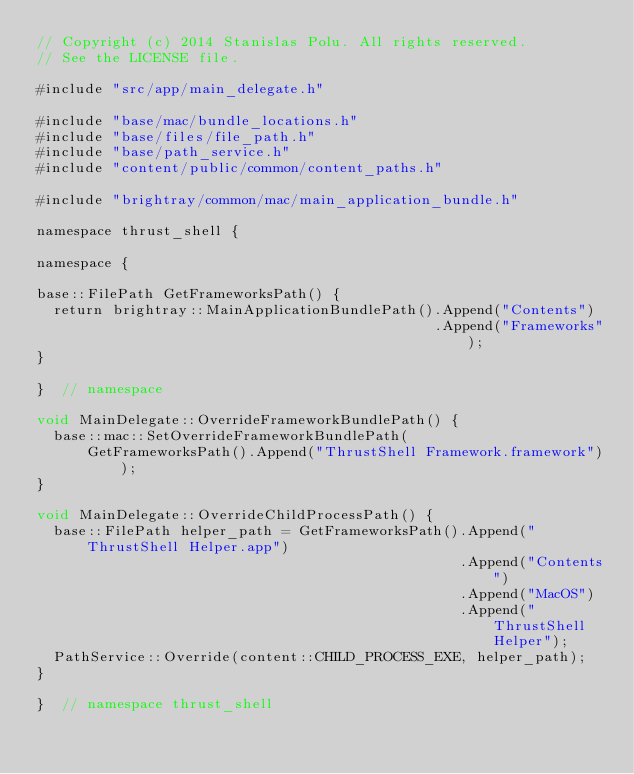Convert code to text. <code><loc_0><loc_0><loc_500><loc_500><_ObjectiveC_>// Copyright (c) 2014 Stanislas Polu. All rights reserved.
// See the LICENSE file.

#include "src/app/main_delegate.h"

#include "base/mac/bundle_locations.h"
#include "base/files/file_path.h"
#include "base/path_service.h"
#include "content/public/common/content_paths.h"

#include "brightray/common/mac/main_application_bundle.h"

namespace thrust_shell {

namespace {

base::FilePath GetFrameworksPath() {
  return brightray::MainApplicationBundlePath().Append("Contents")
                                               .Append("Frameworks");
}

}  // namespace

void MainDelegate::OverrideFrameworkBundlePath() {
  base::mac::SetOverrideFrameworkBundlePath(
      GetFrameworksPath().Append("ThrustShell Framework.framework"));
}

void MainDelegate::OverrideChildProcessPath() {
  base::FilePath helper_path = GetFrameworksPath().Append("ThrustShell Helper.app")
                                                  .Append("Contents")
                                                  .Append("MacOS")
                                                  .Append("ThrustShell Helper");
  PathService::Override(content::CHILD_PROCESS_EXE, helper_path);
}

}  // namespace thrust_shell
</code> 